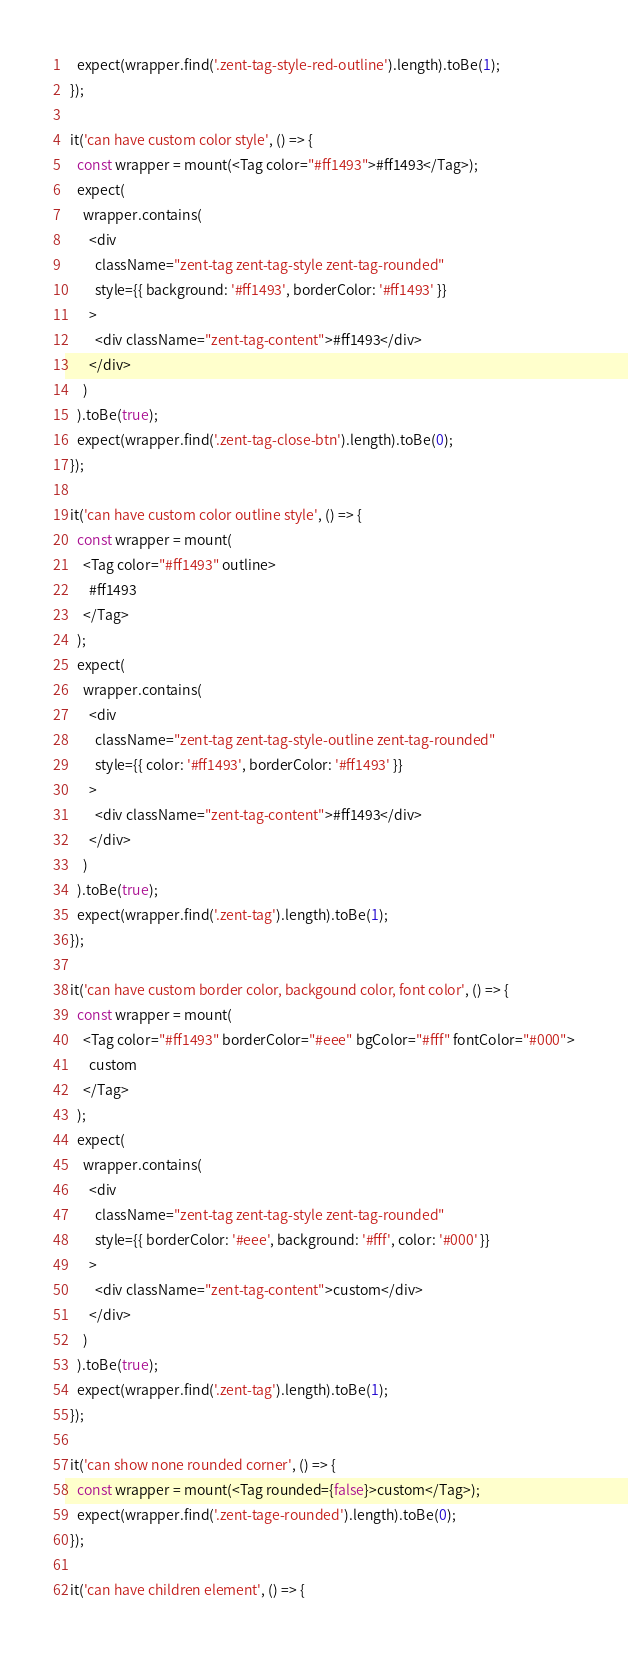Convert code to text. <code><loc_0><loc_0><loc_500><loc_500><_JavaScript_>    expect(wrapper.find('.zent-tag-style-red-outline').length).toBe(1);
  });

  it('can have custom color style', () => {
    const wrapper = mount(<Tag color="#ff1493">#ff1493</Tag>);
    expect(
      wrapper.contains(
        <div
          className="zent-tag zent-tag-style zent-tag-rounded"
          style={{ background: '#ff1493', borderColor: '#ff1493' }}
        >
          <div className="zent-tag-content">#ff1493</div>
        </div>
      )
    ).toBe(true);
    expect(wrapper.find('.zent-tag-close-btn').length).toBe(0);
  });

  it('can have custom color outline style', () => {
    const wrapper = mount(
      <Tag color="#ff1493" outline>
        #ff1493
      </Tag>
    );
    expect(
      wrapper.contains(
        <div
          className="zent-tag zent-tag-style-outline zent-tag-rounded"
          style={{ color: '#ff1493', borderColor: '#ff1493' }}
        >
          <div className="zent-tag-content">#ff1493</div>
        </div>
      )
    ).toBe(true);
    expect(wrapper.find('.zent-tag').length).toBe(1);
  });

  it('can have custom border color, backgound color, font color', () => {
    const wrapper = mount(
      <Tag color="#ff1493" borderColor="#eee" bgColor="#fff" fontColor="#000">
        custom
      </Tag>
    );
    expect(
      wrapper.contains(
        <div
          className="zent-tag zent-tag-style zent-tag-rounded"
          style={{ borderColor: '#eee', background: '#fff', color: '#000' }}
        >
          <div className="zent-tag-content">custom</div>
        </div>
      )
    ).toBe(true);
    expect(wrapper.find('.zent-tag').length).toBe(1);
  });

  it('can show none rounded corner', () => {
    const wrapper = mount(<Tag rounded={false}>custom</Tag>);
    expect(wrapper.find('.zent-tage-rounded').length).toBe(0);
  });

  it('can have children element', () => {</code> 